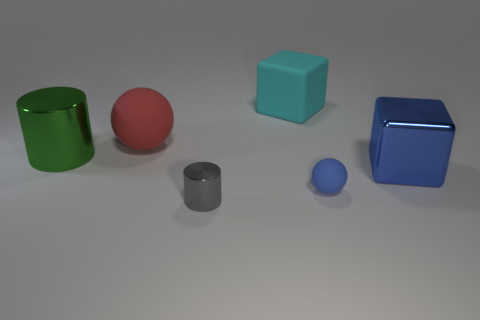The small object that is the same material as the green cylinder is what color? gray 